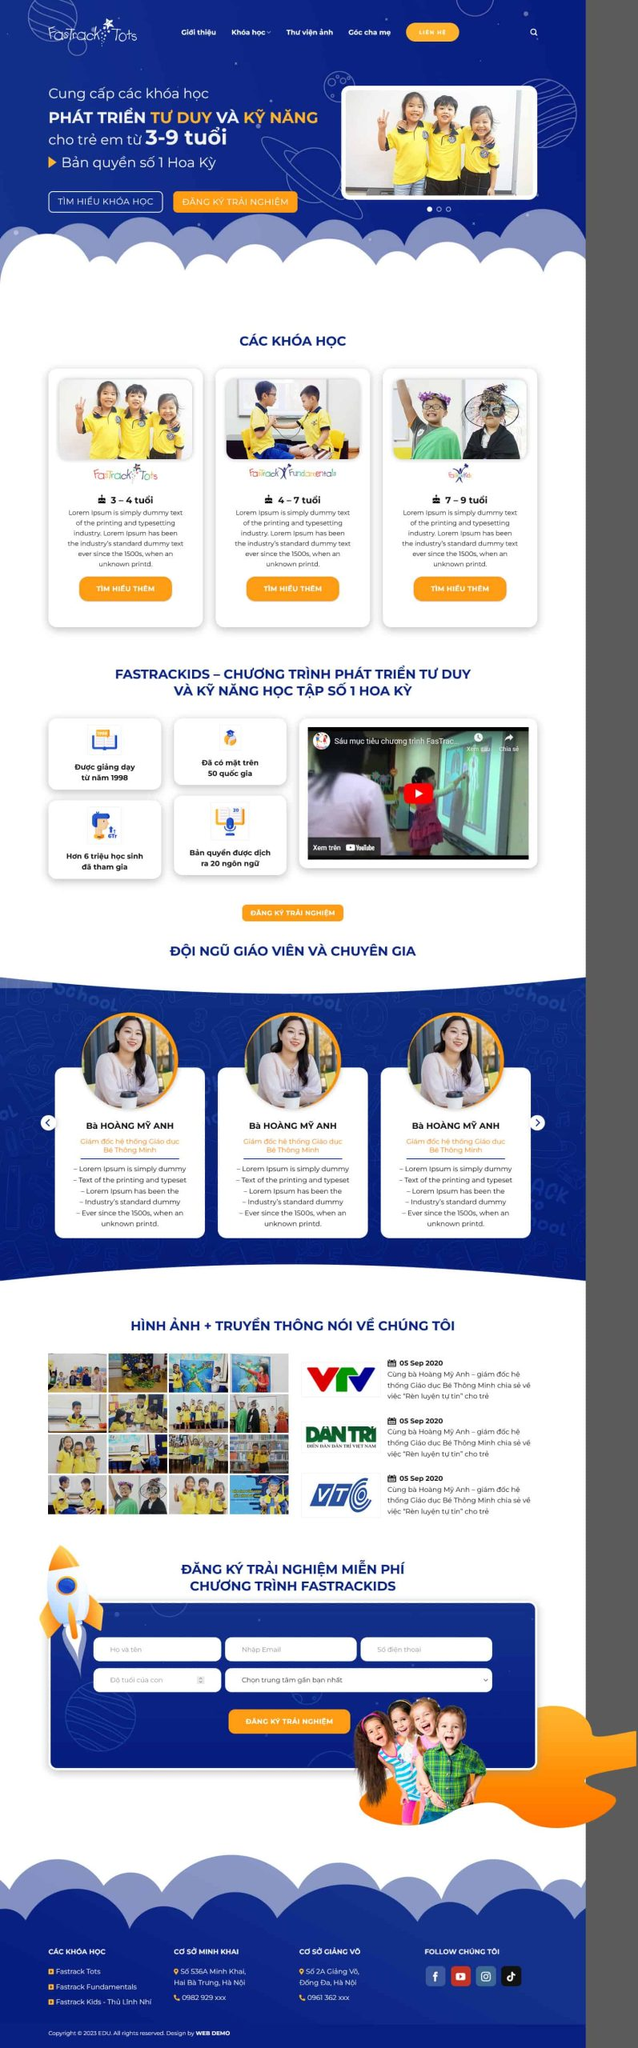Liệt kê 5 ngành nghề, lĩnh vực phù hợp với website này, phân cách các màu sắc bằng dấu phẩy. Chỉ trả về kết quả, phân cách bằng dấy phẩy
 Giáo dục, Đào tạo kỹ năng mềm, Phát triển tư duy, Giáo dục sớm, Chương trình học cho trẻ em 